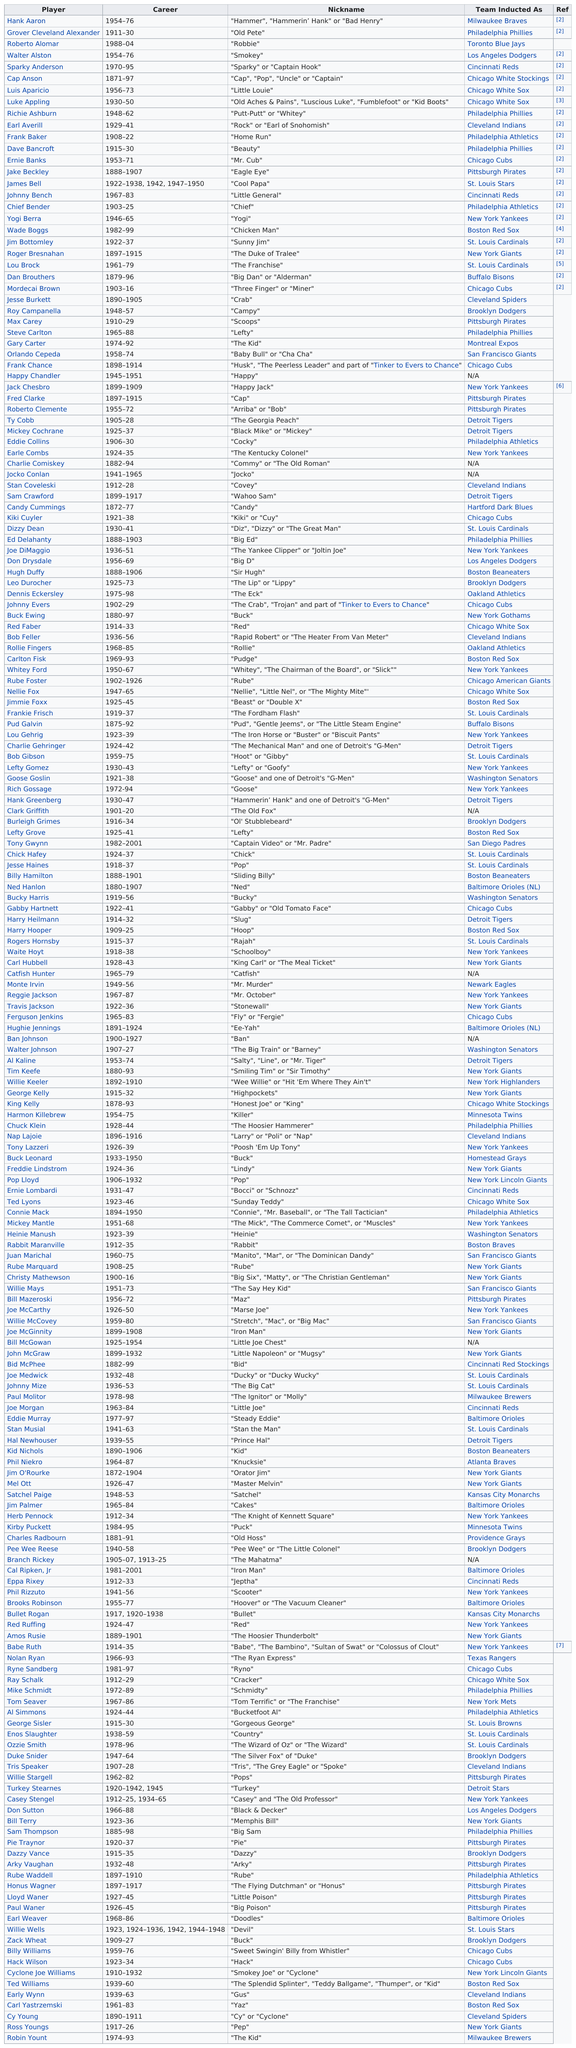Indicate a few pertinent items in this graphic. Eight players were inducted as players of the Philadelphia Phillies. Hear ye, hear ye! The first player to don the jersey of the St. Louis Cardinals was none other than the illustrious Rogers Hornsby! Cap Anson played professional baseball for a total of 26 years. Out of the total number of players, 5 had nicknames that started with the letter W. I, Tom Seaver, also known as Tom Terrific and the Franchise, am a talented baseball player. 